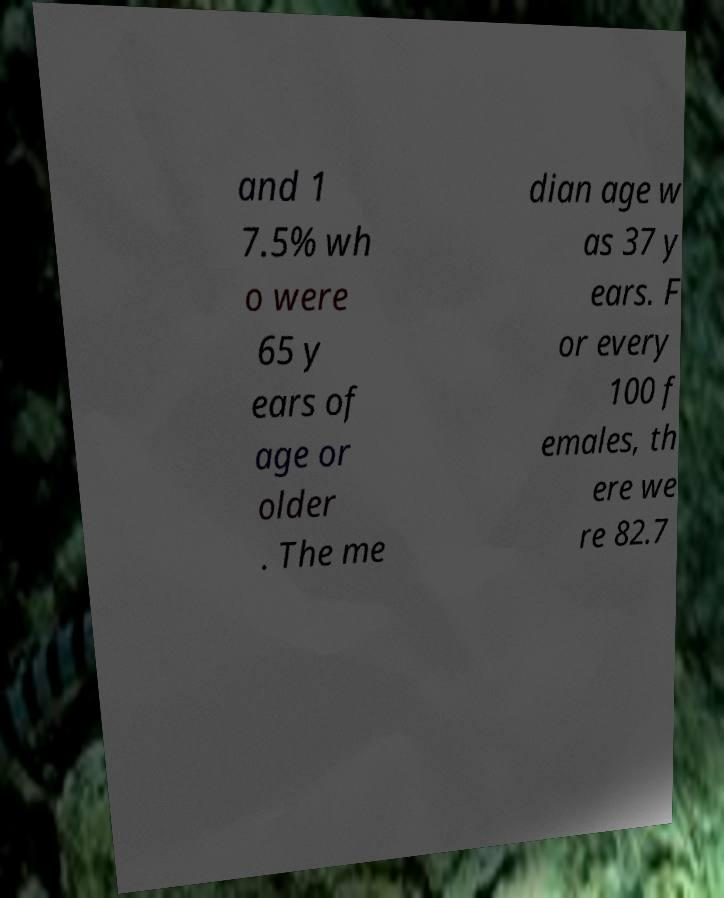Please read and relay the text visible in this image. What does it say? and 1 7.5% wh o were 65 y ears of age or older . The me dian age w as 37 y ears. F or every 100 f emales, th ere we re 82.7 